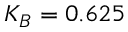<formula> <loc_0><loc_0><loc_500><loc_500>K _ { B } = 0 . 6 2 5</formula> 